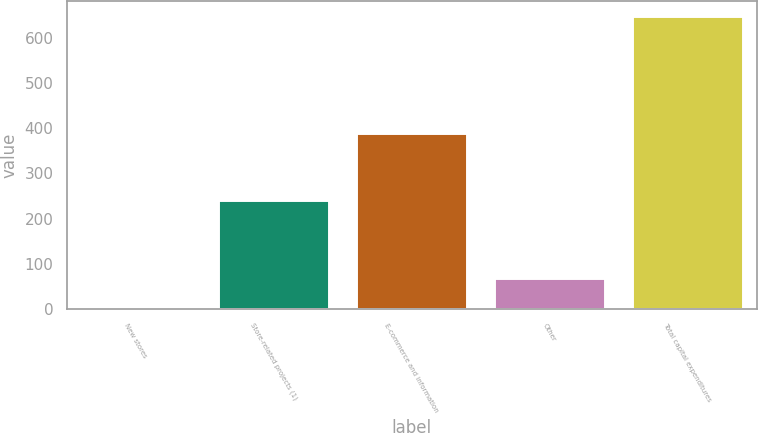Convert chart. <chart><loc_0><loc_0><loc_500><loc_500><bar_chart><fcel>New stores<fcel>Store-related projects (1)<fcel>E-commerce and information<fcel>Other<fcel>Total capital expenditures<nl><fcel>5<fcel>241<fcel>390<fcel>69.4<fcel>649<nl></chart> 